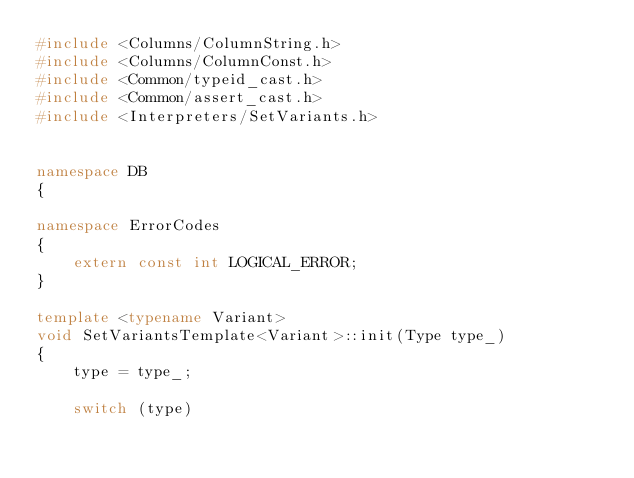<code> <loc_0><loc_0><loc_500><loc_500><_C++_>#include <Columns/ColumnString.h>
#include <Columns/ColumnConst.h>
#include <Common/typeid_cast.h>
#include <Common/assert_cast.h>
#include <Interpreters/SetVariants.h>


namespace DB
{

namespace ErrorCodes
{
    extern const int LOGICAL_ERROR;
}

template <typename Variant>
void SetVariantsTemplate<Variant>::init(Type type_)
{
    type = type_;

    switch (type)</code> 